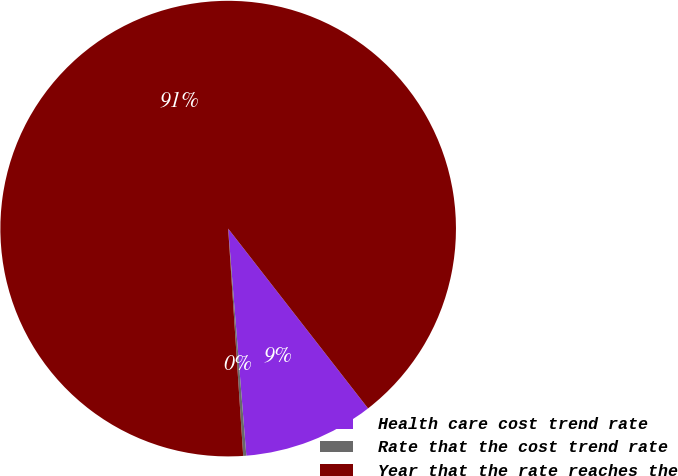Convert chart. <chart><loc_0><loc_0><loc_500><loc_500><pie_chart><fcel>Health care cost trend rate<fcel>Rate that the cost trend rate<fcel>Year that the rate reaches the<nl><fcel>9.25%<fcel>0.22%<fcel>90.52%<nl></chart> 